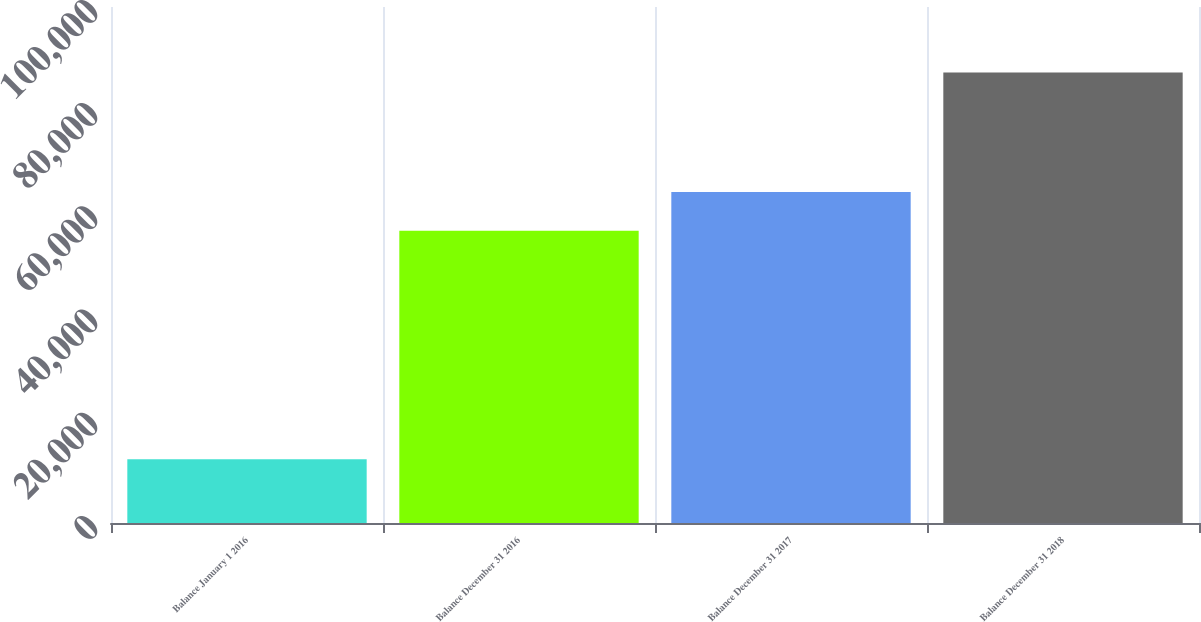<chart> <loc_0><loc_0><loc_500><loc_500><bar_chart><fcel>Balance January 1 2016<fcel>Balance December 31 2016<fcel>Balance December 31 2017<fcel>Balance December 31 2018<nl><fcel>12357<fcel>56635<fcel>64128.7<fcel>87294<nl></chart> 